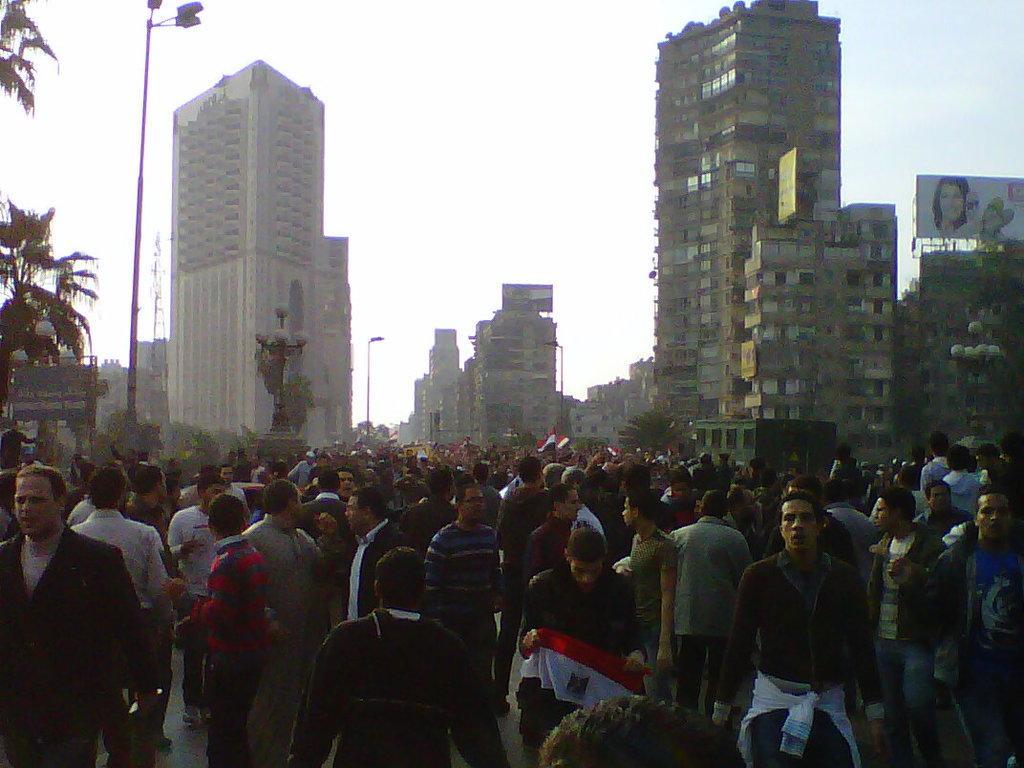Describe this image in one or two sentences. In this picture there are group of people and there are buildings and trees and street lights and there are hoardings. At the top there is sky. At the bottom there is a road. At the back there might be a statue and few people are holding the flags. 